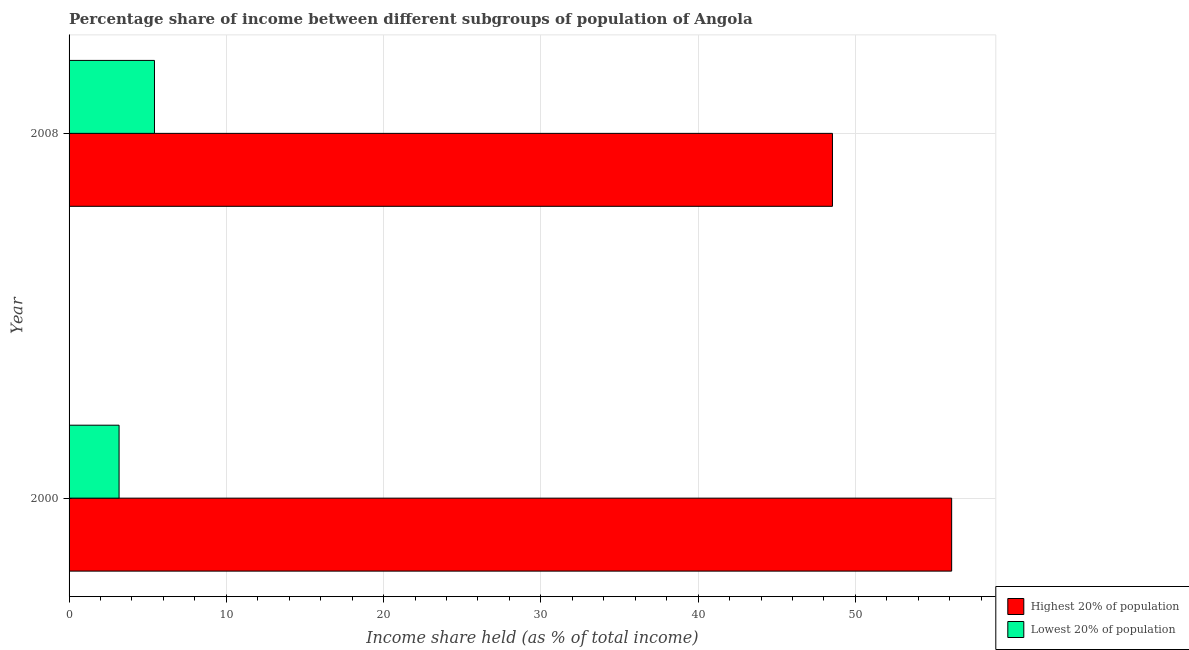How many different coloured bars are there?
Keep it short and to the point. 2. How many groups of bars are there?
Your response must be concise. 2. Are the number of bars per tick equal to the number of legend labels?
Provide a succinct answer. Yes. Are the number of bars on each tick of the Y-axis equal?
Offer a very short reply. Yes. How many bars are there on the 1st tick from the bottom?
Ensure brevity in your answer.  2. What is the label of the 1st group of bars from the top?
Offer a very short reply. 2008. In how many cases, is the number of bars for a given year not equal to the number of legend labels?
Make the answer very short. 0. What is the income share held by highest 20% of the population in 2000?
Keep it short and to the point. 56.12. Across all years, what is the maximum income share held by lowest 20% of the population?
Keep it short and to the point. 5.43. Across all years, what is the minimum income share held by highest 20% of the population?
Offer a terse response. 48.54. What is the total income share held by highest 20% of the population in the graph?
Your answer should be compact. 104.66. What is the difference between the income share held by highest 20% of the population in 2000 and that in 2008?
Keep it short and to the point. 7.58. What is the difference between the income share held by lowest 20% of the population in 2000 and the income share held by highest 20% of the population in 2008?
Provide a short and direct response. -45.36. What is the average income share held by lowest 20% of the population per year?
Your answer should be very brief. 4.3. In the year 2000, what is the difference between the income share held by lowest 20% of the population and income share held by highest 20% of the population?
Your response must be concise. -52.94. What is the ratio of the income share held by highest 20% of the population in 2000 to that in 2008?
Offer a terse response. 1.16. In how many years, is the income share held by highest 20% of the population greater than the average income share held by highest 20% of the population taken over all years?
Your answer should be very brief. 1. What does the 2nd bar from the top in 2000 represents?
Give a very brief answer. Highest 20% of population. What does the 2nd bar from the bottom in 2000 represents?
Your response must be concise. Lowest 20% of population. Are all the bars in the graph horizontal?
Your answer should be compact. Yes. What is the difference between two consecutive major ticks on the X-axis?
Your response must be concise. 10. Does the graph contain any zero values?
Offer a terse response. No. Where does the legend appear in the graph?
Provide a short and direct response. Bottom right. What is the title of the graph?
Provide a succinct answer. Percentage share of income between different subgroups of population of Angola. Does "Revenue" appear as one of the legend labels in the graph?
Provide a short and direct response. No. What is the label or title of the X-axis?
Keep it short and to the point. Income share held (as % of total income). What is the label or title of the Y-axis?
Keep it short and to the point. Year. What is the Income share held (as % of total income) in Highest 20% of population in 2000?
Offer a terse response. 56.12. What is the Income share held (as % of total income) of Lowest 20% of population in 2000?
Offer a terse response. 3.18. What is the Income share held (as % of total income) in Highest 20% of population in 2008?
Your answer should be compact. 48.54. What is the Income share held (as % of total income) of Lowest 20% of population in 2008?
Make the answer very short. 5.43. Across all years, what is the maximum Income share held (as % of total income) of Highest 20% of population?
Provide a succinct answer. 56.12. Across all years, what is the maximum Income share held (as % of total income) of Lowest 20% of population?
Provide a short and direct response. 5.43. Across all years, what is the minimum Income share held (as % of total income) of Highest 20% of population?
Give a very brief answer. 48.54. Across all years, what is the minimum Income share held (as % of total income) in Lowest 20% of population?
Offer a very short reply. 3.18. What is the total Income share held (as % of total income) of Highest 20% of population in the graph?
Offer a terse response. 104.66. What is the total Income share held (as % of total income) of Lowest 20% of population in the graph?
Keep it short and to the point. 8.61. What is the difference between the Income share held (as % of total income) of Highest 20% of population in 2000 and that in 2008?
Keep it short and to the point. 7.58. What is the difference between the Income share held (as % of total income) in Lowest 20% of population in 2000 and that in 2008?
Ensure brevity in your answer.  -2.25. What is the difference between the Income share held (as % of total income) of Highest 20% of population in 2000 and the Income share held (as % of total income) of Lowest 20% of population in 2008?
Your answer should be compact. 50.69. What is the average Income share held (as % of total income) of Highest 20% of population per year?
Offer a very short reply. 52.33. What is the average Income share held (as % of total income) of Lowest 20% of population per year?
Your answer should be compact. 4.3. In the year 2000, what is the difference between the Income share held (as % of total income) of Highest 20% of population and Income share held (as % of total income) of Lowest 20% of population?
Make the answer very short. 52.94. In the year 2008, what is the difference between the Income share held (as % of total income) of Highest 20% of population and Income share held (as % of total income) of Lowest 20% of population?
Keep it short and to the point. 43.11. What is the ratio of the Income share held (as % of total income) of Highest 20% of population in 2000 to that in 2008?
Keep it short and to the point. 1.16. What is the ratio of the Income share held (as % of total income) of Lowest 20% of population in 2000 to that in 2008?
Ensure brevity in your answer.  0.59. What is the difference between the highest and the second highest Income share held (as % of total income) of Highest 20% of population?
Ensure brevity in your answer.  7.58. What is the difference between the highest and the second highest Income share held (as % of total income) in Lowest 20% of population?
Ensure brevity in your answer.  2.25. What is the difference between the highest and the lowest Income share held (as % of total income) in Highest 20% of population?
Make the answer very short. 7.58. What is the difference between the highest and the lowest Income share held (as % of total income) of Lowest 20% of population?
Your answer should be compact. 2.25. 